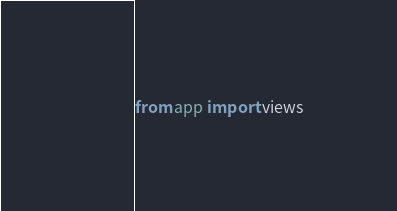Convert code to text. <code><loc_0><loc_0><loc_500><loc_500><_Python_>
from app import views
</code> 